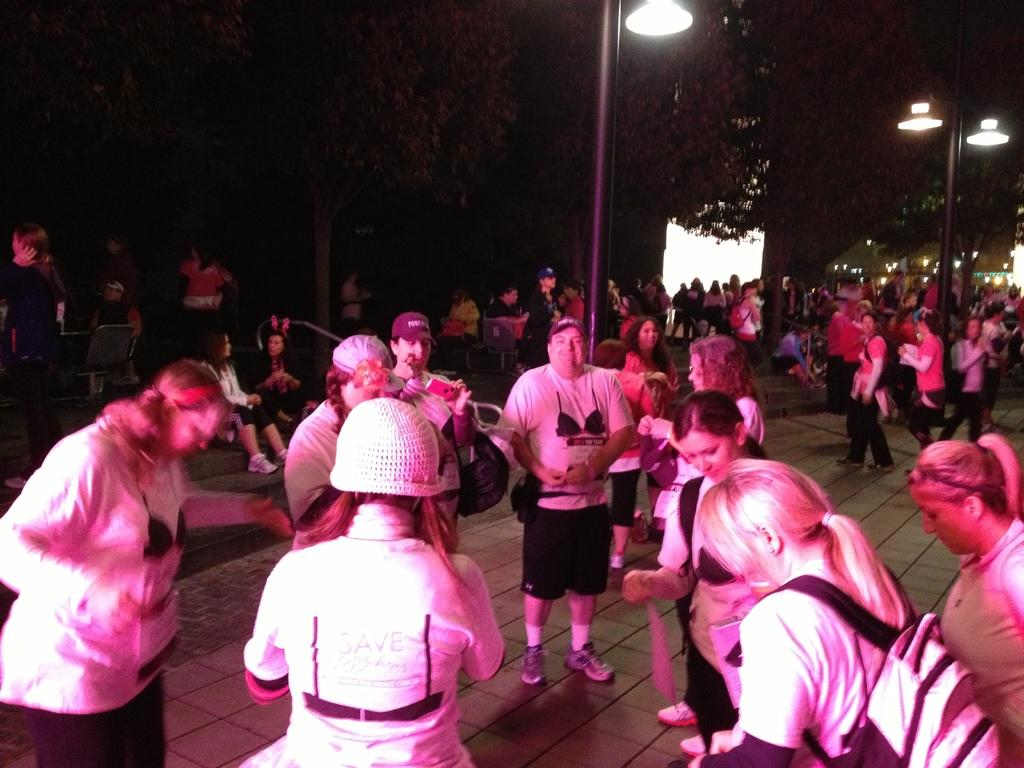What is happening on the road in the image? There are people on the road in the image. What can be seen in the distance in the image? There are trees in the background of the image. What structures are present along the road in the image? There are light poles in the image. What time of day is the image taken? The image is taken during night time. What type of creature is causing a power shock in the image? There is no creature or power shock present in the image. How does the shock affect the people on the road in the image? There is no shock or any indication of an electrical issue in the image. 